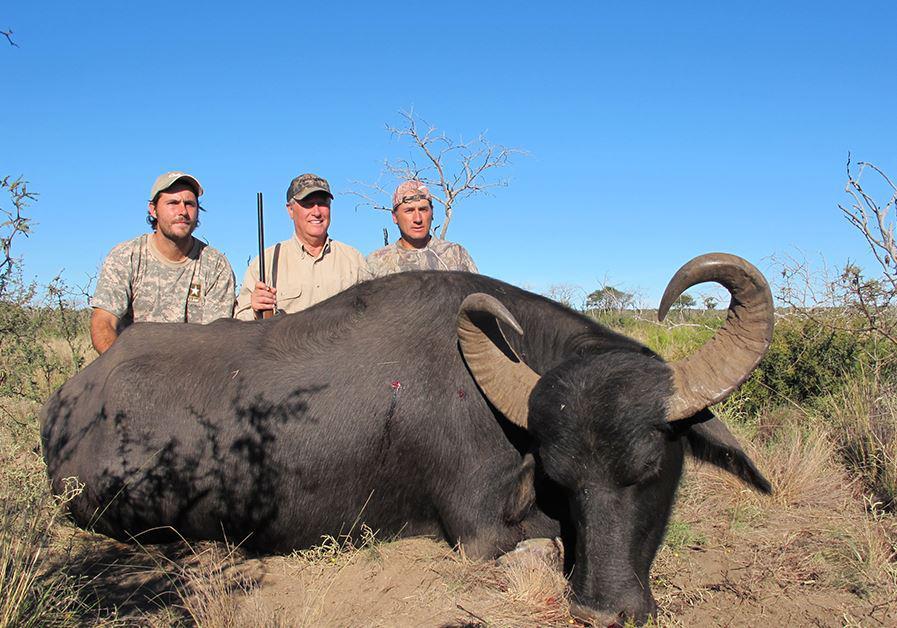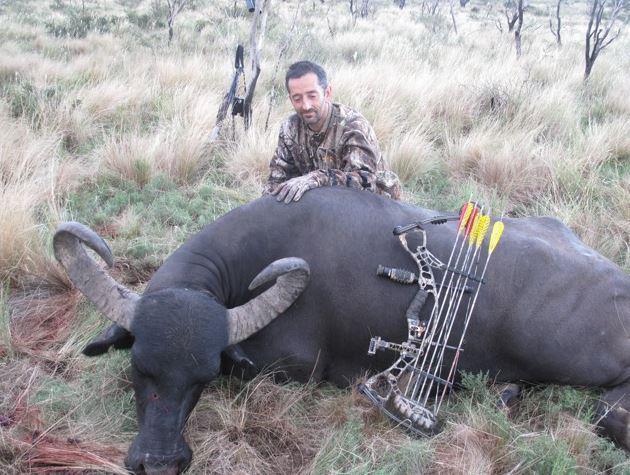The first image is the image on the left, the second image is the image on the right. Analyze the images presented: Is the assertion "The left image contains three humans posing with a dead water buffalo." valid? Answer yes or no. Yes. The first image is the image on the left, the second image is the image on the right. Given the left and right images, does the statement "Three hunters with one gun pose behind a downed water buffalo in one image, and one man poses with his weapon and a dead water buffalo in the other image." hold true? Answer yes or no. Yes. 